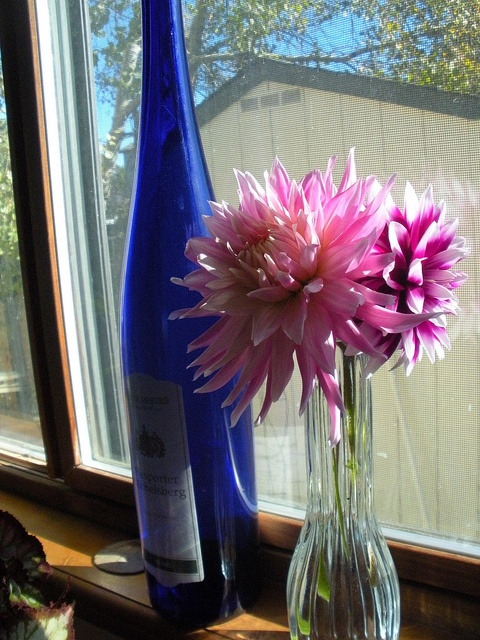Describe the objects in this image and their specific colors. I can see bottle in black, navy, darkblue, and gray tones and vase in black, darkgray, gray, and darkgreen tones in this image. 